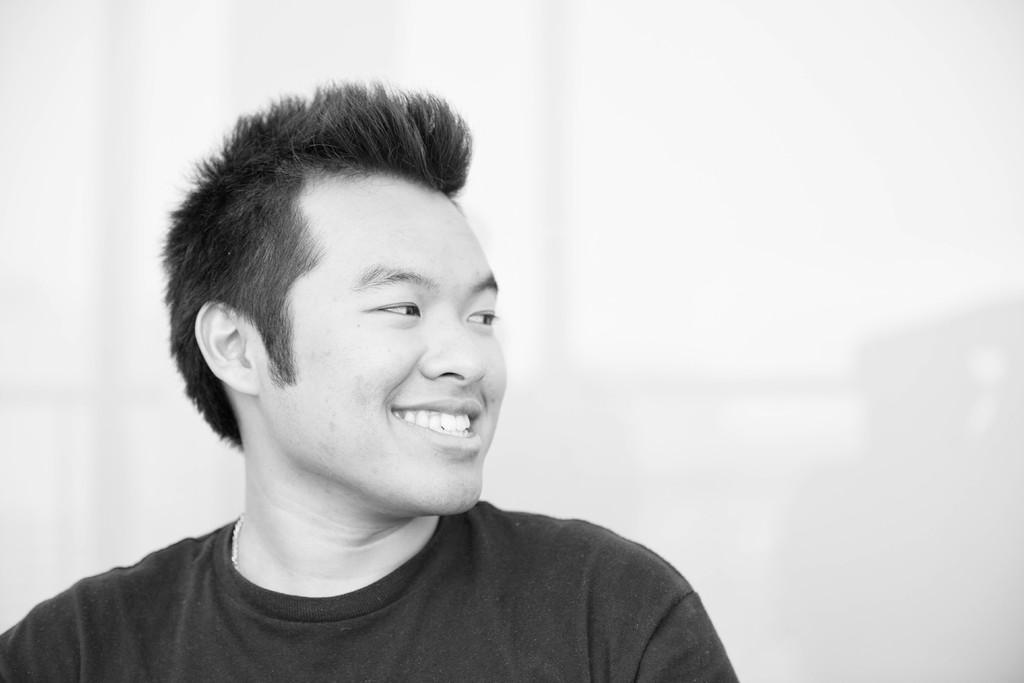Could you give a brief overview of what you see in this image? This is a black and white picture. In the picture there is a man wearing a t-shirt, he is smiling. The picture has white background. 